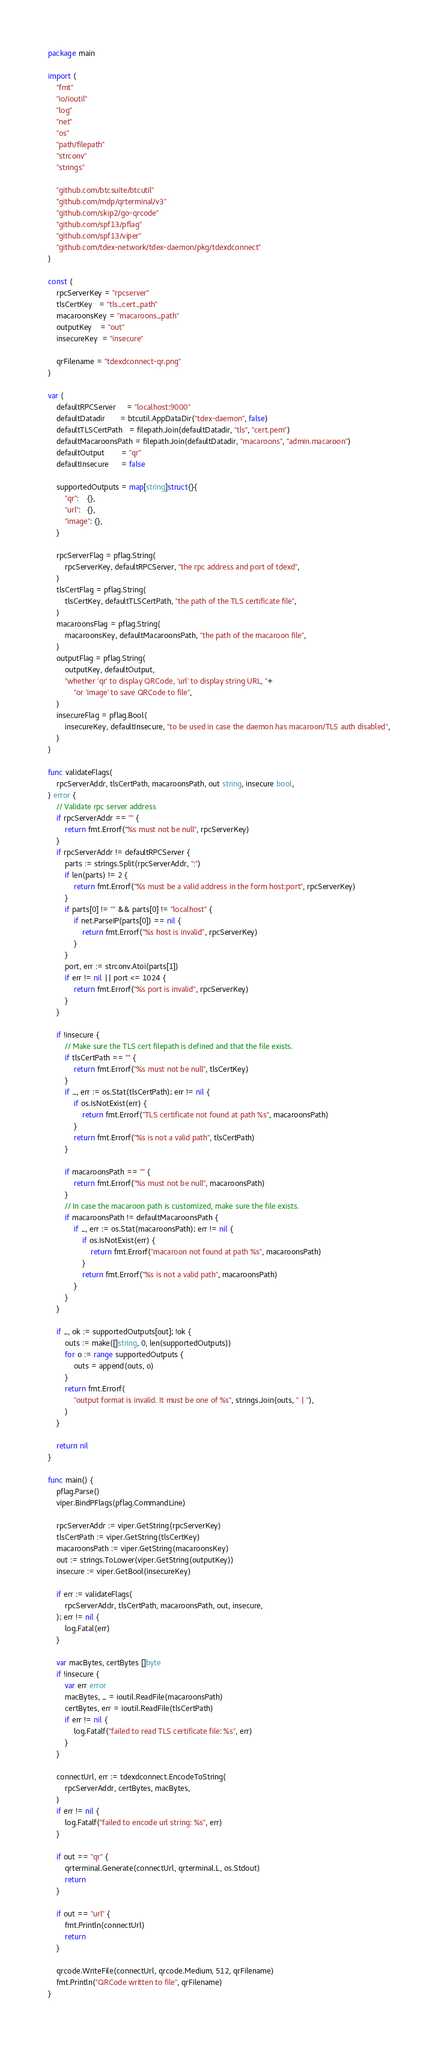<code> <loc_0><loc_0><loc_500><loc_500><_Go_>package main

import (
	"fmt"
	"io/ioutil"
	"log"
	"net"
	"os"
	"path/filepath"
	"strconv"
	"strings"

	"github.com/btcsuite/btcutil"
	"github.com/mdp/qrterminal/v3"
	"github.com/skip2/go-qrcode"
	"github.com/spf13/pflag"
	"github.com/spf13/viper"
	"github.com/tdex-network/tdex-daemon/pkg/tdexdconnect"
)

const (
	rpcServerKey = "rpcserver"
	tlsCertKey   = "tls_cert_path"
	macaroonsKey = "macaroons_path"
	outputKey    = "out"
	insecureKey  = "insecure"

	qrFilename = "tdexdconnect-qr.png"
)

var (
	defaultRPCServer     = "localhost:9000"
	defaultDatadir       = btcutil.AppDataDir("tdex-daemon", false)
	defaultTLSCertPath   = filepath.Join(defaultDatadir, "tls", "cert.pem")
	defaultMacaroonsPath = filepath.Join(defaultDatadir, "macaroons", "admin.macaroon")
	defaultOutput        = "qr"
	defaultInsecure      = false

	supportedOutputs = map[string]struct{}{
		"qr":    {},
		"url":   {},
		"image": {},
	}

	rpcServerFlag = pflag.String(
		rpcServerKey, defaultRPCServer, "the rpc address and port of tdexd",
	)
	tlsCertFlag = pflag.String(
		tlsCertKey, defaultTLSCertPath, "the path of the TLS certificate file",
	)
	macaroonsFlag = pflag.String(
		macaroonsKey, defaultMacaroonsPath, "the path of the macaroon file",
	)
	outputFlag = pflag.String(
		outputKey, defaultOutput,
		"whether 'qr' to display QRCode, 'url' to display string URL, "+
			"or 'image' to save QRCode to file",
	)
	insecureFlag = pflag.Bool(
		insecureKey, defaultInsecure, "to be used in case the daemon has macaroon/TLS auth disabled",
	)
)

func validateFlags(
	rpcServerAddr, tlsCertPath, macaroonsPath, out string, insecure bool,
) error {
	// Validate rpc server address
	if rpcServerAddr == "" {
		return fmt.Errorf("%s must not be null", rpcServerKey)
	}
	if rpcServerAddr != defaultRPCServer {
		parts := strings.Split(rpcServerAddr, ":")
		if len(parts) != 2 {
			return fmt.Errorf("%s must be a valid address in the form host:port", rpcServerKey)
		}
		if parts[0] != "" && parts[0] != "localhost" {
			if net.ParseIP(parts[0]) == nil {
				return fmt.Errorf("%s host is invalid", rpcServerKey)
			}
		}
		port, err := strconv.Atoi(parts[1])
		if err != nil || port <= 1024 {
			return fmt.Errorf("%s port is invalid", rpcServerKey)
		}
	}

	if !insecure {
		// Make sure the TLS cert filepath is defined and that the file exists.
		if tlsCertPath == "" {
			return fmt.Errorf("%s must not be null", tlsCertKey)
		}
		if _, err := os.Stat(tlsCertPath); err != nil {
			if os.IsNotExist(err) {
				return fmt.Errorf("TLS certificate not found at path %s", macaroonsPath)
			}
			return fmt.Errorf("%s is not a valid path", tlsCertPath)
		}

		if macaroonsPath == "" {
			return fmt.Errorf("%s must not be null", macaroonsPath)
		}
		// In case the macaroon path is customized, make sure the file exists.
		if macaroonsPath != defaultMacaroonsPath {
			if _, err := os.Stat(macaroonsPath); err != nil {
				if os.IsNotExist(err) {
					return fmt.Errorf("macaroon not found at path %s", macaroonsPath)
				}
				return fmt.Errorf("%s is not a valid path", macaroonsPath)
			}
		}
	}

	if _, ok := supportedOutputs[out]; !ok {
		outs := make([]string, 0, len(supportedOutputs))
		for o := range supportedOutputs {
			outs = append(outs, o)
		}
		return fmt.Errorf(
			"output format is invalid. It must be one of %s", strings.Join(outs, " | "),
		)
	}

	return nil
}

func main() {
	pflag.Parse()
	viper.BindPFlags(pflag.CommandLine)

	rpcServerAddr := viper.GetString(rpcServerKey)
	tlsCertPath := viper.GetString(tlsCertKey)
	macaroonsPath := viper.GetString(macaroonsKey)
	out := strings.ToLower(viper.GetString(outputKey))
	insecure := viper.GetBool(insecureKey)

	if err := validateFlags(
		rpcServerAddr, tlsCertPath, macaroonsPath, out, insecure,
	); err != nil {
		log.Fatal(err)
	}

	var macBytes, certBytes []byte
	if !insecure {
		var err error
		macBytes, _ = ioutil.ReadFile(macaroonsPath)
		certBytes, err = ioutil.ReadFile(tlsCertPath)
		if err != nil {
			log.Fatalf("failed to read TLS certificate file: %s", err)
		}
	}

	connectUrl, err := tdexdconnect.EncodeToString(
		rpcServerAddr, certBytes, macBytes,
	)
	if err != nil {
		log.Fatalf("failed to encode url string: %s", err)
	}

	if out == "qr" {
		qrterminal.Generate(connectUrl, qrterminal.L, os.Stdout)
		return
	}

	if out == "url" {
		fmt.Println(connectUrl)
		return
	}

	qrcode.WriteFile(connectUrl, qrcode.Medium, 512, qrFilename)
	fmt.Println("QRCode written to file", qrFilename)
}
</code> 